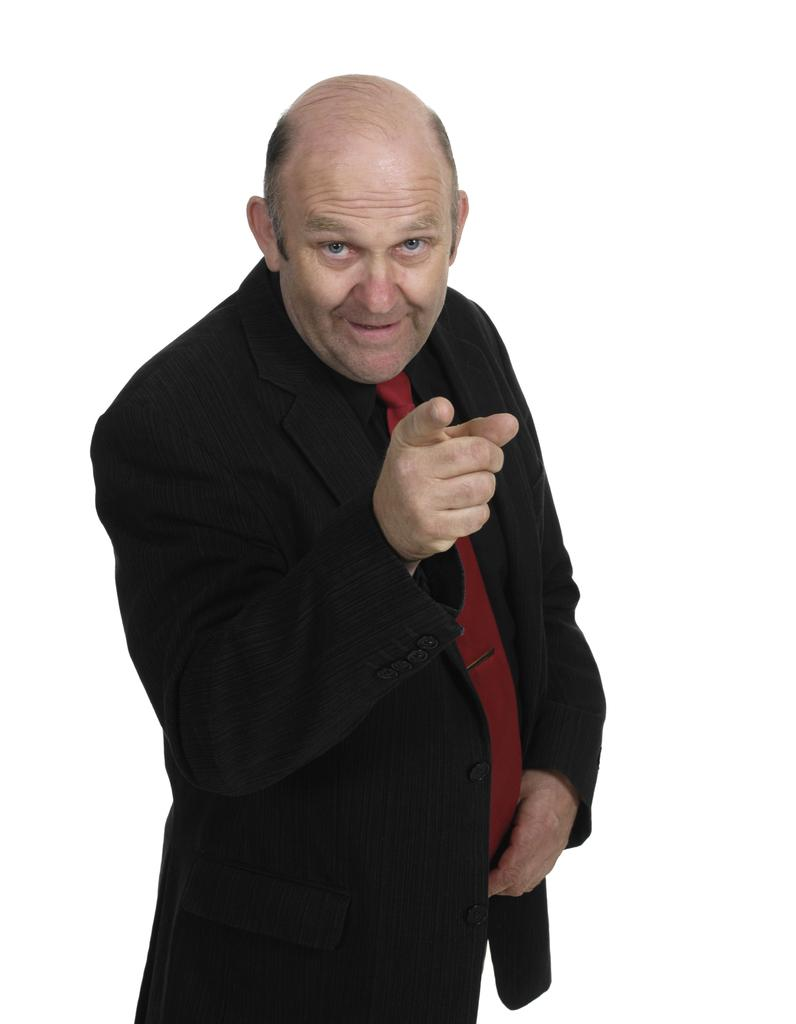Who is the main subject in the image? There is a man in the image. What is the man wearing? The man is wearing a black coat. What is the man's facial expression in the image? The man is smiling. What is the color of the background in the image? The background of the image is white. What is the condition of the man's voice in the image? There is no information about the man's voice in the image, as it is a still photograph. What type of apparel is the man wearing on his feet? There is no information about the man's footwear in the image. 